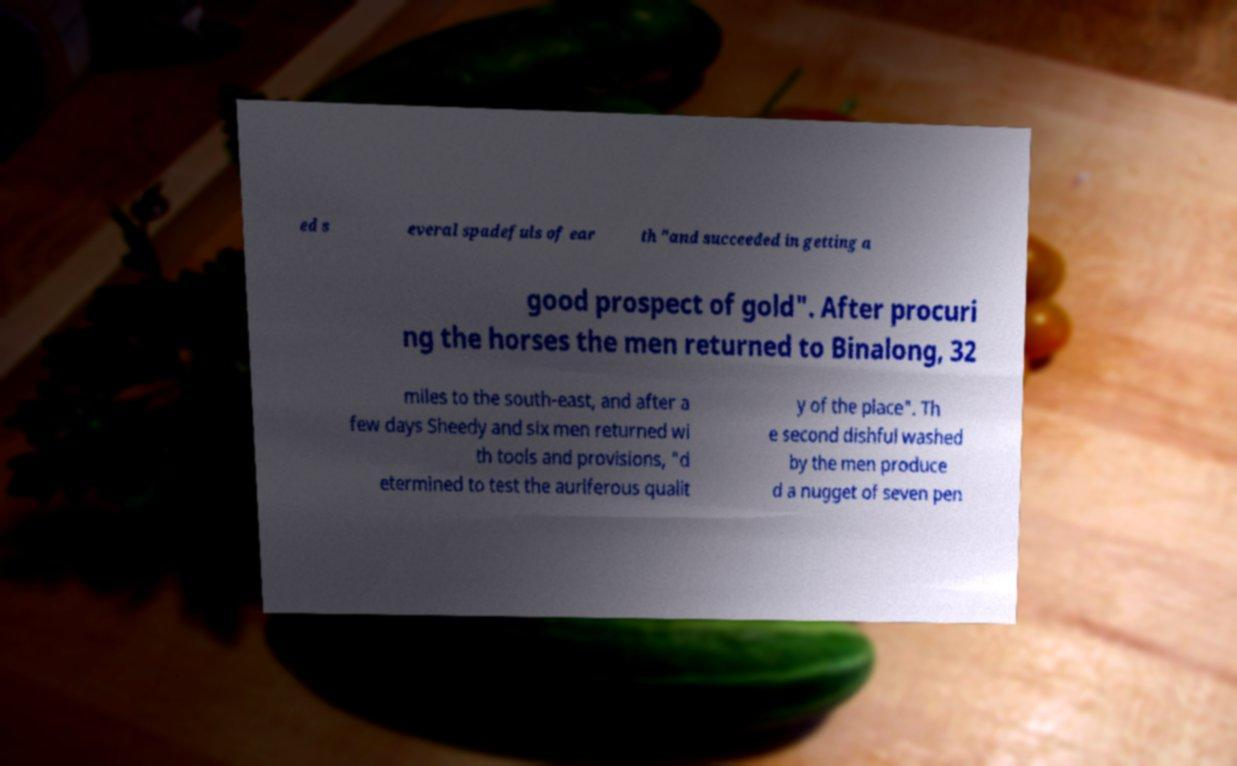Please identify and transcribe the text found in this image. ed s everal spadefuls of ear th "and succeeded in getting a good prospect of gold". After procuri ng the horses the men returned to Binalong, 32 miles to the south-east, and after a few days Sheedy and six men returned wi th tools and provisions, "d etermined to test the auriferous qualit y of the place". Th e second dishful washed by the men produce d a nugget of seven pen 